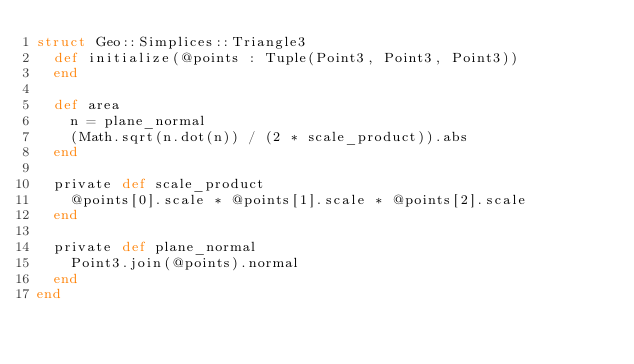Convert code to text. <code><loc_0><loc_0><loc_500><loc_500><_Crystal_>struct Geo::Simplices::Triangle3
  def initialize(@points : Tuple(Point3, Point3, Point3))
  end

  def area
    n = plane_normal
    (Math.sqrt(n.dot(n)) / (2 * scale_product)).abs
  end

  private def scale_product
    @points[0].scale * @points[1].scale * @points[2].scale
  end

  private def plane_normal
    Point3.join(@points).normal
  end
end
</code> 